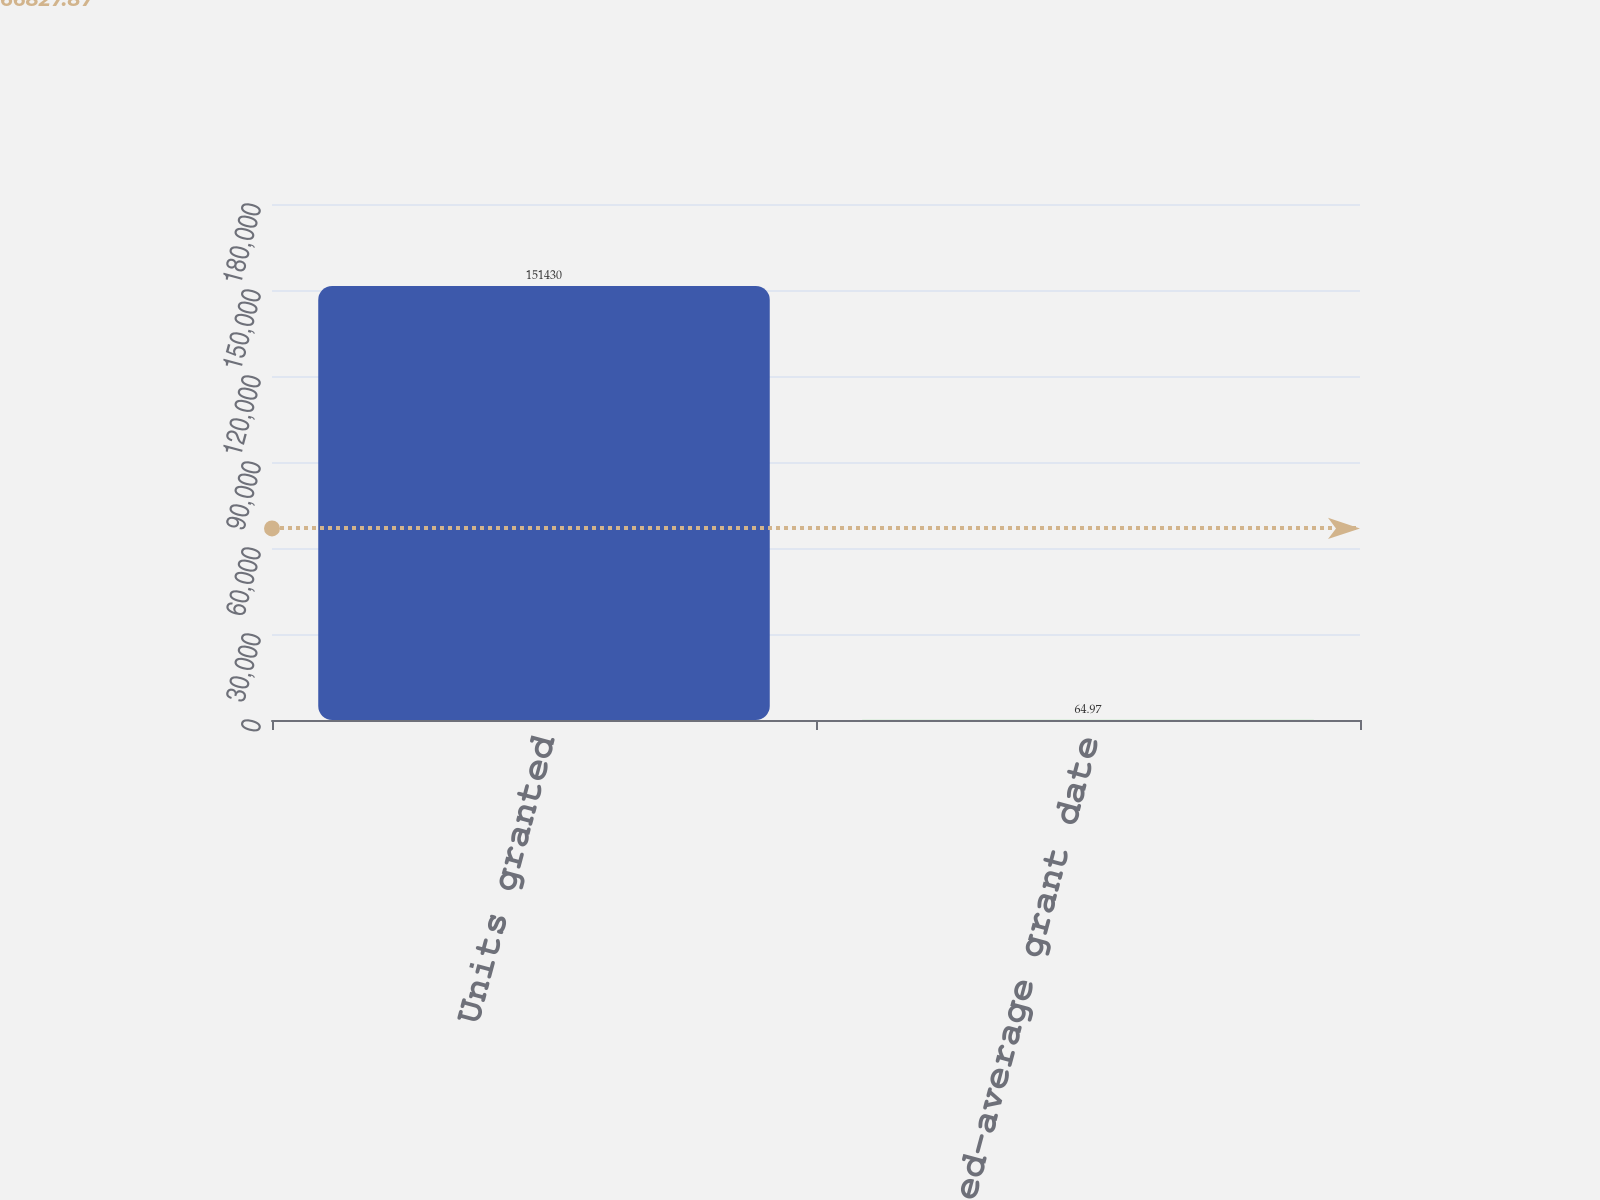Convert chart. <chart><loc_0><loc_0><loc_500><loc_500><bar_chart><fcel>Units granted<fcel>Weighted-average grant date<nl><fcel>151430<fcel>64.97<nl></chart> 